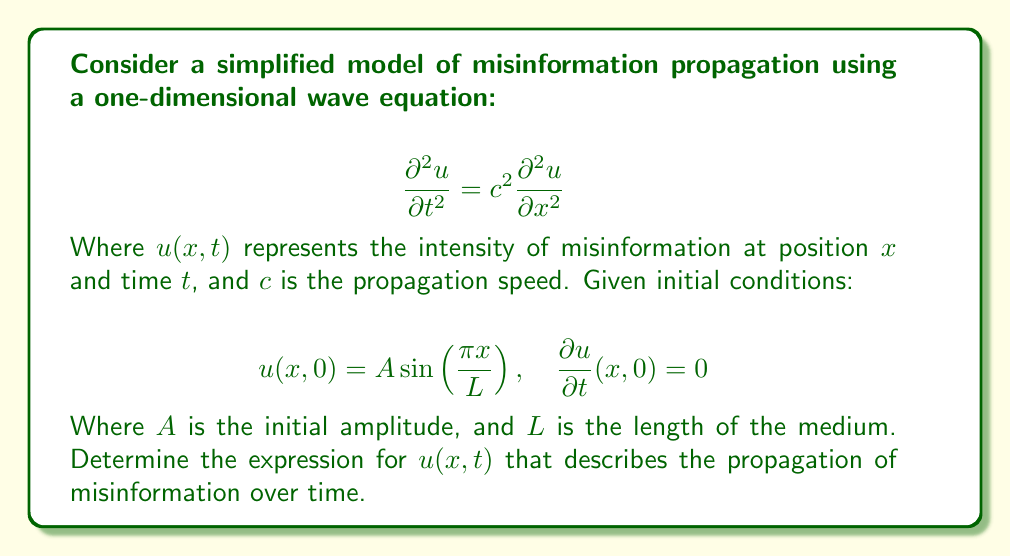Teach me how to tackle this problem. To solve this problem, we'll follow these steps:

1) The general solution for the one-dimensional wave equation is:

   $$u(x,t) = f(x-ct) + g(x+ct)$$

   Where $f$ and $g$ are arbitrary functions.

2) Given the initial condition $u(x,0) = A \sin(\frac{\pi x}{L})$, we can deduce:

   $$f(x) + g(x) = A \sin(\frac{\pi x}{L})$$

3) The second initial condition $\frac{\partial u}{\partial t}(x,0) = 0$ implies:

   $$-cf'(x) + cg'(x) = 0$$

   Therefore, $f'(x) = g'(x)$

4) This suggests that $f(x) = g(x) = \frac{1}{2}A \sin(\frac{\pi x}{L})$

5) Substituting these into the general solution:

   $$u(x,t) = \frac{1}{2}A \sin(\frac{\pi (x-ct)}{L}) + \frac{1}{2}A \sin(\frac{\pi (x+ct)}{L})$$

6) Using the trigonometric identity for the sum of sines:

   $$\sin A + \sin B = 2 \sin(\frac{A+B}{2}) \cos(\frac{A-B}{2})$$

7) We get:

   $$u(x,t) = A \sin(\frac{\pi x}{L}) \cos(\frac{\pi ct}{L})$$

This expression describes how the initial sinusoidal distribution of misinformation propagates as a standing wave over time.
Answer: $$u(x,t) = A \sin(\frac{\pi x}{L}) \cos(\frac{\pi ct}{L})$$ 